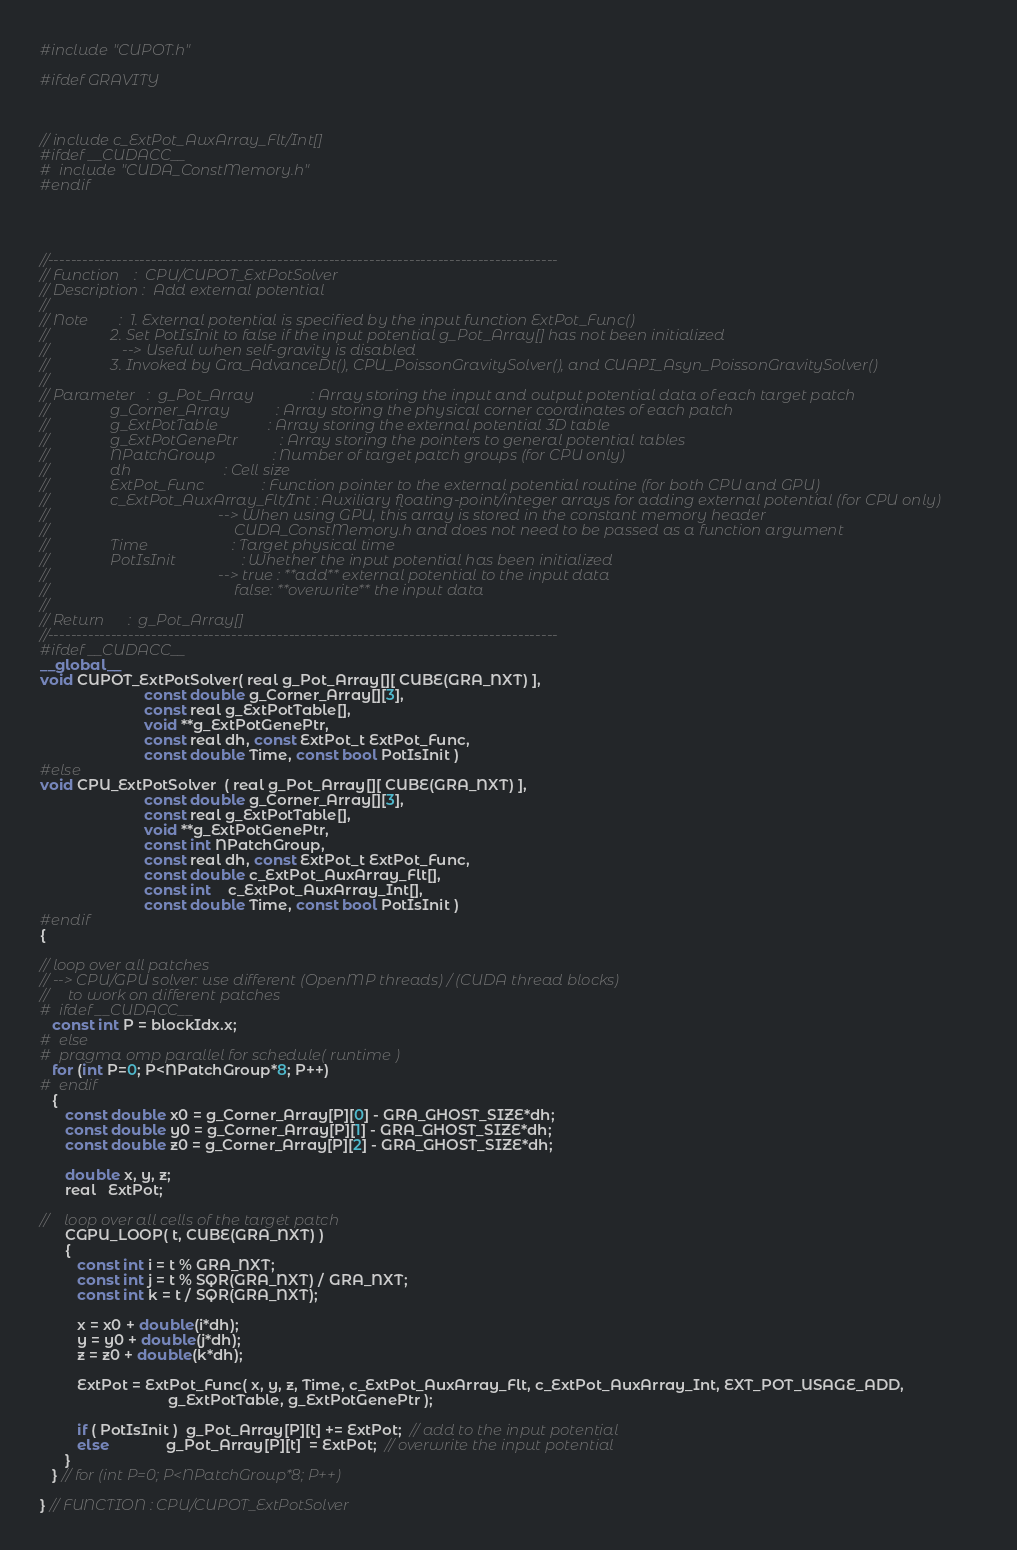Convert code to text. <code><loc_0><loc_0><loc_500><loc_500><_Cuda_>#include "CUPOT.h"

#ifdef GRAVITY



// include c_ExtPot_AuxArray_Flt/Int[]
#ifdef __CUDACC__
#  include "CUDA_ConstMemory.h"
#endif




//-----------------------------------------------------------------------------------------
// Function    :  CPU/CUPOT_ExtPotSolver
// Description :  Add external potential
//
// Note        :  1. External potential is specified by the input function ExtPot_Func()
//                2. Set PotIsInit to false if the input potential g_Pot_Array[] has not been initialized
//                   --> Useful when self-gravity is disabled
//                3. Invoked by Gra_AdvanceDt(), CPU_PoissonGravitySolver(), and CUAPI_Asyn_PoissonGravitySolver()
//
// Parameter   :  g_Pot_Array               : Array storing the input and output potential data of each target patch
//                g_Corner_Array            : Array storing the physical corner coordinates of each patch
//                g_ExtPotTable             : Array storing the external potential 3D table
//                g_ExtPotGenePtr           : Array storing the pointers to general potential tables
//                NPatchGroup               : Number of target patch groups (for CPU only)
//                dh                        : Cell size
//                ExtPot_Func               : Function pointer to the external potential routine (for both CPU and GPU)
//                c_ExtPot_AuxArray_Flt/Int : Auxiliary floating-point/integer arrays for adding external potential (for CPU only)
//                                            --> When using GPU, this array is stored in the constant memory header
//                                                CUDA_ConstMemory.h and does not need to be passed as a function argument
//                Time                      : Target physical time
//                PotIsInit                 : Whether the input potential has been initialized
//                                            --> true : **add** external potential to the input data
//                                                false: **overwrite** the input data
//
// Return      :  g_Pot_Array[]
//-----------------------------------------------------------------------------------------
#ifdef __CUDACC__
__global__
void CUPOT_ExtPotSolver( real g_Pot_Array[][ CUBE(GRA_NXT) ],
                         const double g_Corner_Array[][3],
                         const real g_ExtPotTable[],
                         void **g_ExtPotGenePtr,
                         const real dh, const ExtPot_t ExtPot_Func,
                         const double Time, const bool PotIsInit )
#else
void CPU_ExtPotSolver  ( real g_Pot_Array[][ CUBE(GRA_NXT) ],
                         const double g_Corner_Array[][3],
                         const real g_ExtPotTable[],
                         void **g_ExtPotGenePtr,
                         const int NPatchGroup,
                         const real dh, const ExtPot_t ExtPot_Func,
                         const double c_ExtPot_AuxArray_Flt[],
                         const int    c_ExtPot_AuxArray_Int[],
                         const double Time, const bool PotIsInit )
#endif
{

// loop over all patches
// --> CPU/GPU solver: use different (OpenMP threads) / (CUDA thread blocks)
//     to work on different patches
#  ifdef __CUDACC__
   const int P = blockIdx.x;
#  else
#  pragma omp parallel for schedule( runtime )
   for (int P=0; P<NPatchGroup*8; P++)
#  endif
   {
      const double x0 = g_Corner_Array[P][0] - GRA_GHOST_SIZE*dh;
      const double y0 = g_Corner_Array[P][1] - GRA_GHOST_SIZE*dh;
      const double z0 = g_Corner_Array[P][2] - GRA_GHOST_SIZE*dh;

      double x, y, z;
      real   ExtPot;

//    loop over all cells of the target patch
      CGPU_LOOP( t, CUBE(GRA_NXT) )
      {
         const int i = t % GRA_NXT;
         const int j = t % SQR(GRA_NXT) / GRA_NXT;
         const int k = t / SQR(GRA_NXT);

         x = x0 + double(i*dh);
         y = y0 + double(j*dh);
         z = z0 + double(k*dh);

         ExtPot = ExtPot_Func( x, y, z, Time, c_ExtPot_AuxArray_Flt, c_ExtPot_AuxArray_Int, EXT_POT_USAGE_ADD,
                               g_ExtPotTable, g_ExtPotGenePtr );

         if ( PotIsInit )  g_Pot_Array[P][t] += ExtPot;  // add to the input potential
         else              g_Pot_Array[P][t]  = ExtPot;  // overwrite the input potential
      }
   } // for (int P=0; P<NPatchGroup*8; P++)

} // FUNCTION : CPU/CUPOT_ExtPotSolver


</code> 